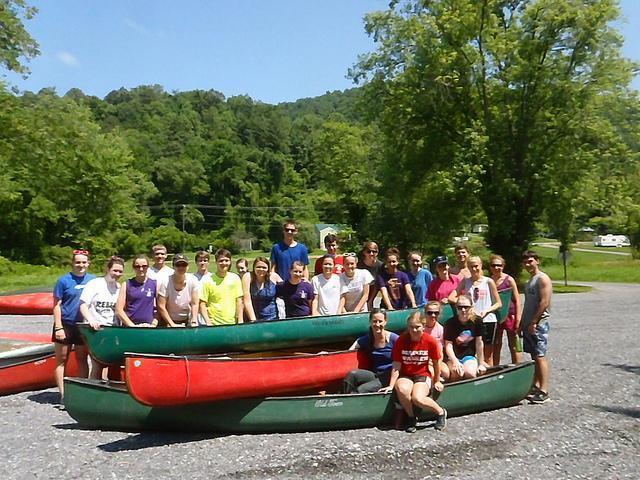How many boats are green?
Give a very brief answer. 2. How many boats can you see?
Give a very brief answer. 2. How many people are there?
Give a very brief answer. 10. 